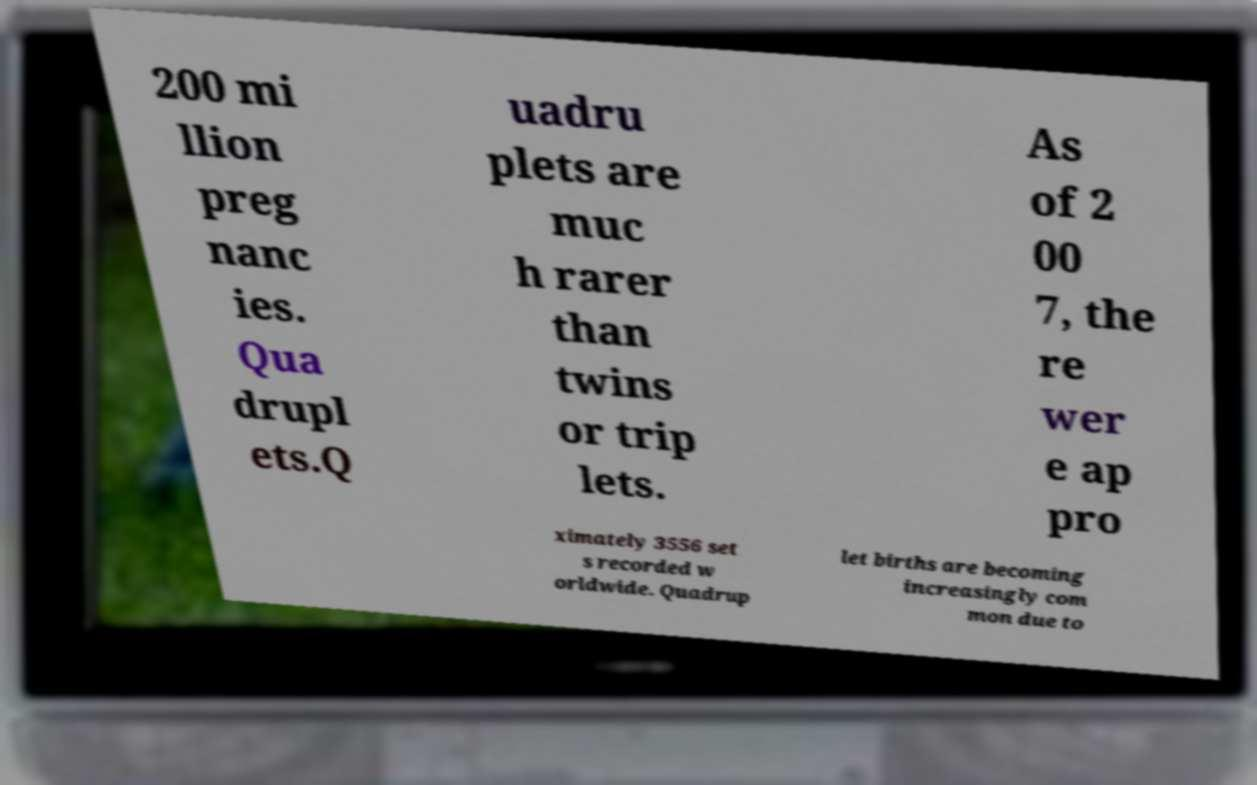There's text embedded in this image that I need extracted. Can you transcribe it verbatim? 200 mi llion preg nanc ies. Qua drupl ets.Q uadru plets are muc h rarer than twins or trip lets. As of 2 00 7, the re wer e ap pro ximately 3556 set s recorded w orldwide. Quadrup let births are becoming increasingly com mon due to 